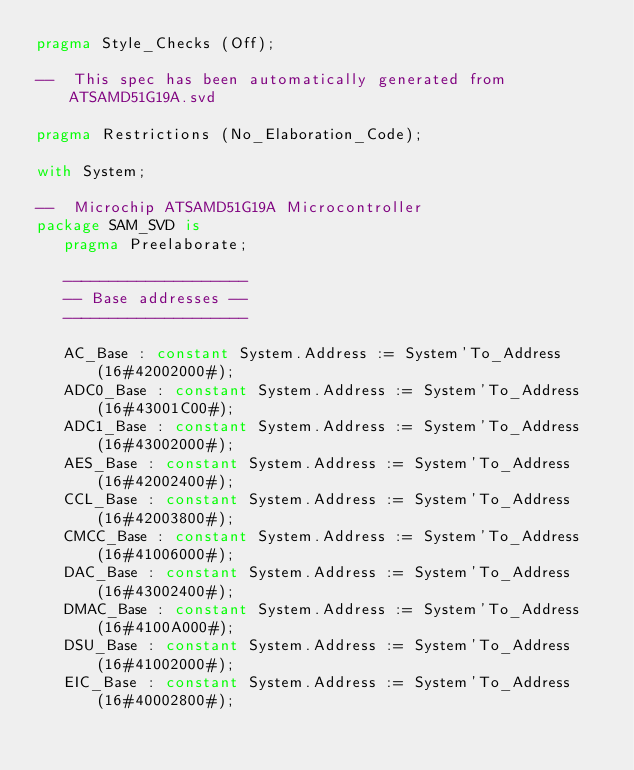Convert code to text. <code><loc_0><loc_0><loc_500><loc_500><_Ada_>pragma Style_Checks (Off);

--  This spec has been automatically generated from ATSAMD51G19A.svd

pragma Restrictions (No_Elaboration_Code);

with System;

--  Microchip ATSAMD51G19A Microcontroller
package SAM_SVD is
   pragma Preelaborate;

   --------------------
   -- Base addresses --
   --------------------

   AC_Base : constant System.Address := System'To_Address (16#42002000#);
   ADC0_Base : constant System.Address := System'To_Address (16#43001C00#);
   ADC1_Base : constant System.Address := System'To_Address (16#43002000#);
   AES_Base : constant System.Address := System'To_Address (16#42002400#);
   CCL_Base : constant System.Address := System'To_Address (16#42003800#);
   CMCC_Base : constant System.Address := System'To_Address (16#41006000#);
   DAC_Base : constant System.Address := System'To_Address (16#43002400#);
   DMAC_Base : constant System.Address := System'To_Address (16#4100A000#);
   DSU_Base : constant System.Address := System'To_Address (16#41002000#);
   EIC_Base : constant System.Address := System'To_Address (16#40002800#);</code> 